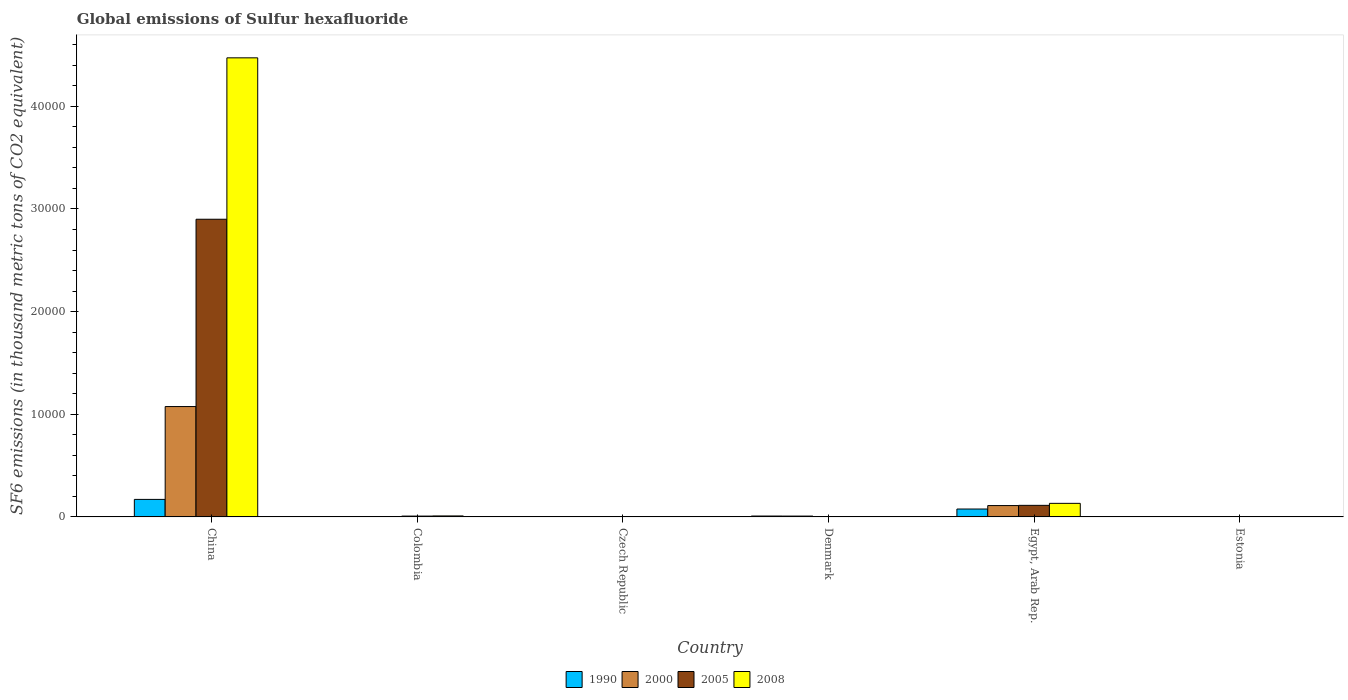How many different coloured bars are there?
Your answer should be very brief. 4. How many bars are there on the 4th tick from the right?
Your response must be concise. 4. In how many cases, is the number of bars for a given country not equal to the number of legend labels?
Your answer should be compact. 0. What is the global emissions of Sulfur hexafluoride in 2000 in Denmark?
Provide a succinct answer. 81.4. Across all countries, what is the maximum global emissions of Sulfur hexafluoride in 2000?
Provide a succinct answer. 1.08e+04. In which country was the global emissions of Sulfur hexafluoride in 2005 minimum?
Make the answer very short. Estonia. What is the total global emissions of Sulfur hexafluoride in 1990 in the graph?
Your answer should be very brief. 2611.6. What is the difference between the global emissions of Sulfur hexafluoride in 1990 in Denmark and that in Egypt, Arab Rep.?
Provide a short and direct response. -683. What is the difference between the global emissions of Sulfur hexafluoride in 2005 in Denmark and the global emissions of Sulfur hexafluoride in 2000 in Czech Republic?
Provide a succinct answer. 18.5. What is the average global emissions of Sulfur hexafluoride in 2000 per country?
Ensure brevity in your answer.  1997.55. What is the difference between the global emissions of Sulfur hexafluoride of/in 2000 and global emissions of Sulfur hexafluoride of/in 2005 in Czech Republic?
Offer a very short reply. 7.4. What is the ratio of the global emissions of Sulfur hexafluoride in 2000 in Colombia to that in Egypt, Arab Rep.?
Keep it short and to the point. 0.03. Is the global emissions of Sulfur hexafluoride in 2000 in Colombia less than that in Denmark?
Make the answer very short. Yes. Is the difference between the global emissions of Sulfur hexafluoride in 2000 in China and Estonia greater than the difference between the global emissions of Sulfur hexafluoride in 2005 in China and Estonia?
Give a very brief answer. No. What is the difference between the highest and the second highest global emissions of Sulfur hexafluoride in 2000?
Offer a terse response. -1.07e+04. What is the difference between the highest and the lowest global emissions of Sulfur hexafluoride in 1990?
Offer a terse response. 1707. Is the sum of the global emissions of Sulfur hexafluoride in 2000 in Czech Republic and Denmark greater than the maximum global emissions of Sulfur hexafluoride in 1990 across all countries?
Offer a very short reply. No. Is it the case that in every country, the sum of the global emissions of Sulfur hexafluoride in 2000 and global emissions of Sulfur hexafluoride in 1990 is greater than the sum of global emissions of Sulfur hexafluoride in 2005 and global emissions of Sulfur hexafluoride in 2008?
Your response must be concise. No. What does the 4th bar from the left in Estonia represents?
Ensure brevity in your answer.  2008. What does the 4th bar from the right in Egypt, Arab Rep. represents?
Ensure brevity in your answer.  1990. How many countries are there in the graph?
Ensure brevity in your answer.  6. Where does the legend appear in the graph?
Give a very brief answer. Bottom center. How are the legend labels stacked?
Keep it short and to the point. Horizontal. What is the title of the graph?
Your answer should be compact. Global emissions of Sulfur hexafluoride. What is the label or title of the X-axis?
Ensure brevity in your answer.  Country. What is the label or title of the Y-axis?
Offer a very short reply. SF6 emissions (in thousand metric tons of CO2 equivalent). What is the SF6 emissions (in thousand metric tons of CO2 equivalent) of 1990 in China?
Keep it short and to the point. 1708.6. What is the SF6 emissions (in thousand metric tons of CO2 equivalent) in 2000 in China?
Your answer should be very brief. 1.08e+04. What is the SF6 emissions (in thousand metric tons of CO2 equivalent) in 2005 in China?
Offer a terse response. 2.90e+04. What is the SF6 emissions (in thousand metric tons of CO2 equivalent) in 2008 in China?
Give a very brief answer. 4.47e+04. What is the SF6 emissions (in thousand metric tons of CO2 equivalent) of 1990 in Colombia?
Make the answer very short. 41.7. What is the SF6 emissions (in thousand metric tons of CO2 equivalent) in 2000 in Colombia?
Offer a terse response. 28.2. What is the SF6 emissions (in thousand metric tons of CO2 equivalent) of 2005 in Colombia?
Your answer should be compact. 82.9. What is the SF6 emissions (in thousand metric tons of CO2 equivalent) in 2008 in Colombia?
Your response must be concise. 96.7. What is the SF6 emissions (in thousand metric tons of CO2 equivalent) in 1990 in Czech Republic?
Your answer should be compact. 3.3. What is the SF6 emissions (in thousand metric tons of CO2 equivalent) in 2005 in Czech Republic?
Offer a very short reply. 5.6. What is the SF6 emissions (in thousand metric tons of CO2 equivalent) of 1990 in Denmark?
Offer a very short reply. 86.7. What is the SF6 emissions (in thousand metric tons of CO2 equivalent) in 2000 in Denmark?
Your answer should be compact. 81.4. What is the SF6 emissions (in thousand metric tons of CO2 equivalent) of 2005 in Denmark?
Your answer should be compact. 31.5. What is the SF6 emissions (in thousand metric tons of CO2 equivalent) of 2008 in Denmark?
Offer a very short reply. 33.5. What is the SF6 emissions (in thousand metric tons of CO2 equivalent) of 1990 in Egypt, Arab Rep.?
Ensure brevity in your answer.  769.7. What is the SF6 emissions (in thousand metric tons of CO2 equivalent) in 2000 in Egypt, Arab Rep.?
Offer a very short reply. 1107.1. What is the SF6 emissions (in thousand metric tons of CO2 equivalent) in 2005 in Egypt, Arab Rep.?
Offer a terse response. 1127.3. What is the SF6 emissions (in thousand metric tons of CO2 equivalent) in 2008 in Egypt, Arab Rep.?
Provide a succinct answer. 1323.3. What is the SF6 emissions (in thousand metric tons of CO2 equivalent) in 2005 in Estonia?
Your answer should be compact. 2.2. Across all countries, what is the maximum SF6 emissions (in thousand metric tons of CO2 equivalent) in 1990?
Offer a terse response. 1708.6. Across all countries, what is the maximum SF6 emissions (in thousand metric tons of CO2 equivalent) of 2000?
Offer a very short reply. 1.08e+04. Across all countries, what is the maximum SF6 emissions (in thousand metric tons of CO2 equivalent) of 2005?
Offer a terse response. 2.90e+04. Across all countries, what is the maximum SF6 emissions (in thousand metric tons of CO2 equivalent) in 2008?
Offer a terse response. 4.47e+04. Across all countries, what is the minimum SF6 emissions (in thousand metric tons of CO2 equivalent) in 2000?
Ensure brevity in your answer.  2. What is the total SF6 emissions (in thousand metric tons of CO2 equivalent) in 1990 in the graph?
Offer a terse response. 2611.6. What is the total SF6 emissions (in thousand metric tons of CO2 equivalent) of 2000 in the graph?
Provide a short and direct response. 1.20e+04. What is the total SF6 emissions (in thousand metric tons of CO2 equivalent) of 2005 in the graph?
Give a very brief answer. 3.03e+04. What is the total SF6 emissions (in thousand metric tons of CO2 equivalent) of 2008 in the graph?
Provide a short and direct response. 4.62e+04. What is the difference between the SF6 emissions (in thousand metric tons of CO2 equivalent) in 1990 in China and that in Colombia?
Your answer should be compact. 1666.9. What is the difference between the SF6 emissions (in thousand metric tons of CO2 equivalent) of 2000 in China and that in Colombia?
Offer a very short reply. 1.07e+04. What is the difference between the SF6 emissions (in thousand metric tons of CO2 equivalent) of 2005 in China and that in Colombia?
Offer a terse response. 2.89e+04. What is the difference between the SF6 emissions (in thousand metric tons of CO2 equivalent) in 2008 in China and that in Colombia?
Your answer should be compact. 4.46e+04. What is the difference between the SF6 emissions (in thousand metric tons of CO2 equivalent) in 1990 in China and that in Czech Republic?
Make the answer very short. 1705.3. What is the difference between the SF6 emissions (in thousand metric tons of CO2 equivalent) of 2000 in China and that in Czech Republic?
Keep it short and to the point. 1.07e+04. What is the difference between the SF6 emissions (in thousand metric tons of CO2 equivalent) of 2005 in China and that in Czech Republic?
Make the answer very short. 2.90e+04. What is the difference between the SF6 emissions (in thousand metric tons of CO2 equivalent) of 2008 in China and that in Czech Republic?
Your response must be concise. 4.47e+04. What is the difference between the SF6 emissions (in thousand metric tons of CO2 equivalent) of 1990 in China and that in Denmark?
Keep it short and to the point. 1621.9. What is the difference between the SF6 emissions (in thousand metric tons of CO2 equivalent) of 2000 in China and that in Denmark?
Your answer should be compact. 1.07e+04. What is the difference between the SF6 emissions (in thousand metric tons of CO2 equivalent) of 2005 in China and that in Denmark?
Your response must be concise. 2.90e+04. What is the difference between the SF6 emissions (in thousand metric tons of CO2 equivalent) in 2008 in China and that in Denmark?
Offer a terse response. 4.47e+04. What is the difference between the SF6 emissions (in thousand metric tons of CO2 equivalent) of 1990 in China and that in Egypt, Arab Rep.?
Provide a short and direct response. 938.9. What is the difference between the SF6 emissions (in thousand metric tons of CO2 equivalent) of 2000 in China and that in Egypt, Arab Rep.?
Keep it short and to the point. 9646.5. What is the difference between the SF6 emissions (in thousand metric tons of CO2 equivalent) in 2005 in China and that in Egypt, Arab Rep.?
Make the answer very short. 2.79e+04. What is the difference between the SF6 emissions (in thousand metric tons of CO2 equivalent) of 2008 in China and that in Egypt, Arab Rep.?
Make the answer very short. 4.34e+04. What is the difference between the SF6 emissions (in thousand metric tons of CO2 equivalent) in 1990 in China and that in Estonia?
Your answer should be compact. 1707. What is the difference between the SF6 emissions (in thousand metric tons of CO2 equivalent) of 2000 in China and that in Estonia?
Your answer should be compact. 1.08e+04. What is the difference between the SF6 emissions (in thousand metric tons of CO2 equivalent) in 2005 in China and that in Estonia?
Ensure brevity in your answer.  2.90e+04. What is the difference between the SF6 emissions (in thousand metric tons of CO2 equivalent) of 2008 in China and that in Estonia?
Keep it short and to the point. 4.47e+04. What is the difference between the SF6 emissions (in thousand metric tons of CO2 equivalent) in 1990 in Colombia and that in Czech Republic?
Provide a short and direct response. 38.4. What is the difference between the SF6 emissions (in thousand metric tons of CO2 equivalent) of 2000 in Colombia and that in Czech Republic?
Your answer should be very brief. 15.2. What is the difference between the SF6 emissions (in thousand metric tons of CO2 equivalent) of 2005 in Colombia and that in Czech Republic?
Keep it short and to the point. 77.3. What is the difference between the SF6 emissions (in thousand metric tons of CO2 equivalent) of 2008 in Colombia and that in Czech Republic?
Provide a short and direct response. 92. What is the difference between the SF6 emissions (in thousand metric tons of CO2 equivalent) in 1990 in Colombia and that in Denmark?
Make the answer very short. -45. What is the difference between the SF6 emissions (in thousand metric tons of CO2 equivalent) of 2000 in Colombia and that in Denmark?
Offer a very short reply. -53.2. What is the difference between the SF6 emissions (in thousand metric tons of CO2 equivalent) in 2005 in Colombia and that in Denmark?
Keep it short and to the point. 51.4. What is the difference between the SF6 emissions (in thousand metric tons of CO2 equivalent) in 2008 in Colombia and that in Denmark?
Provide a short and direct response. 63.2. What is the difference between the SF6 emissions (in thousand metric tons of CO2 equivalent) of 1990 in Colombia and that in Egypt, Arab Rep.?
Make the answer very short. -728. What is the difference between the SF6 emissions (in thousand metric tons of CO2 equivalent) of 2000 in Colombia and that in Egypt, Arab Rep.?
Your answer should be compact. -1078.9. What is the difference between the SF6 emissions (in thousand metric tons of CO2 equivalent) in 2005 in Colombia and that in Egypt, Arab Rep.?
Ensure brevity in your answer.  -1044.4. What is the difference between the SF6 emissions (in thousand metric tons of CO2 equivalent) of 2008 in Colombia and that in Egypt, Arab Rep.?
Provide a short and direct response. -1226.6. What is the difference between the SF6 emissions (in thousand metric tons of CO2 equivalent) in 1990 in Colombia and that in Estonia?
Offer a very short reply. 40.1. What is the difference between the SF6 emissions (in thousand metric tons of CO2 equivalent) in 2000 in Colombia and that in Estonia?
Ensure brevity in your answer.  26.2. What is the difference between the SF6 emissions (in thousand metric tons of CO2 equivalent) of 2005 in Colombia and that in Estonia?
Your answer should be compact. 80.7. What is the difference between the SF6 emissions (in thousand metric tons of CO2 equivalent) in 2008 in Colombia and that in Estonia?
Provide a succinct answer. 94.4. What is the difference between the SF6 emissions (in thousand metric tons of CO2 equivalent) of 1990 in Czech Republic and that in Denmark?
Your response must be concise. -83.4. What is the difference between the SF6 emissions (in thousand metric tons of CO2 equivalent) of 2000 in Czech Republic and that in Denmark?
Provide a succinct answer. -68.4. What is the difference between the SF6 emissions (in thousand metric tons of CO2 equivalent) of 2005 in Czech Republic and that in Denmark?
Your response must be concise. -25.9. What is the difference between the SF6 emissions (in thousand metric tons of CO2 equivalent) in 2008 in Czech Republic and that in Denmark?
Your response must be concise. -28.8. What is the difference between the SF6 emissions (in thousand metric tons of CO2 equivalent) of 1990 in Czech Republic and that in Egypt, Arab Rep.?
Offer a terse response. -766.4. What is the difference between the SF6 emissions (in thousand metric tons of CO2 equivalent) in 2000 in Czech Republic and that in Egypt, Arab Rep.?
Offer a terse response. -1094.1. What is the difference between the SF6 emissions (in thousand metric tons of CO2 equivalent) of 2005 in Czech Republic and that in Egypt, Arab Rep.?
Ensure brevity in your answer.  -1121.7. What is the difference between the SF6 emissions (in thousand metric tons of CO2 equivalent) of 2008 in Czech Republic and that in Egypt, Arab Rep.?
Your answer should be compact. -1318.6. What is the difference between the SF6 emissions (in thousand metric tons of CO2 equivalent) of 1990 in Czech Republic and that in Estonia?
Make the answer very short. 1.7. What is the difference between the SF6 emissions (in thousand metric tons of CO2 equivalent) in 2005 in Czech Republic and that in Estonia?
Give a very brief answer. 3.4. What is the difference between the SF6 emissions (in thousand metric tons of CO2 equivalent) of 2008 in Czech Republic and that in Estonia?
Ensure brevity in your answer.  2.4. What is the difference between the SF6 emissions (in thousand metric tons of CO2 equivalent) in 1990 in Denmark and that in Egypt, Arab Rep.?
Keep it short and to the point. -683. What is the difference between the SF6 emissions (in thousand metric tons of CO2 equivalent) in 2000 in Denmark and that in Egypt, Arab Rep.?
Make the answer very short. -1025.7. What is the difference between the SF6 emissions (in thousand metric tons of CO2 equivalent) of 2005 in Denmark and that in Egypt, Arab Rep.?
Ensure brevity in your answer.  -1095.8. What is the difference between the SF6 emissions (in thousand metric tons of CO2 equivalent) in 2008 in Denmark and that in Egypt, Arab Rep.?
Provide a short and direct response. -1289.8. What is the difference between the SF6 emissions (in thousand metric tons of CO2 equivalent) in 1990 in Denmark and that in Estonia?
Keep it short and to the point. 85.1. What is the difference between the SF6 emissions (in thousand metric tons of CO2 equivalent) of 2000 in Denmark and that in Estonia?
Keep it short and to the point. 79.4. What is the difference between the SF6 emissions (in thousand metric tons of CO2 equivalent) of 2005 in Denmark and that in Estonia?
Give a very brief answer. 29.3. What is the difference between the SF6 emissions (in thousand metric tons of CO2 equivalent) in 2008 in Denmark and that in Estonia?
Provide a short and direct response. 31.2. What is the difference between the SF6 emissions (in thousand metric tons of CO2 equivalent) of 1990 in Egypt, Arab Rep. and that in Estonia?
Provide a succinct answer. 768.1. What is the difference between the SF6 emissions (in thousand metric tons of CO2 equivalent) in 2000 in Egypt, Arab Rep. and that in Estonia?
Give a very brief answer. 1105.1. What is the difference between the SF6 emissions (in thousand metric tons of CO2 equivalent) in 2005 in Egypt, Arab Rep. and that in Estonia?
Offer a terse response. 1125.1. What is the difference between the SF6 emissions (in thousand metric tons of CO2 equivalent) in 2008 in Egypt, Arab Rep. and that in Estonia?
Keep it short and to the point. 1321. What is the difference between the SF6 emissions (in thousand metric tons of CO2 equivalent) in 1990 in China and the SF6 emissions (in thousand metric tons of CO2 equivalent) in 2000 in Colombia?
Give a very brief answer. 1680.4. What is the difference between the SF6 emissions (in thousand metric tons of CO2 equivalent) in 1990 in China and the SF6 emissions (in thousand metric tons of CO2 equivalent) in 2005 in Colombia?
Provide a succinct answer. 1625.7. What is the difference between the SF6 emissions (in thousand metric tons of CO2 equivalent) of 1990 in China and the SF6 emissions (in thousand metric tons of CO2 equivalent) of 2008 in Colombia?
Make the answer very short. 1611.9. What is the difference between the SF6 emissions (in thousand metric tons of CO2 equivalent) of 2000 in China and the SF6 emissions (in thousand metric tons of CO2 equivalent) of 2005 in Colombia?
Your response must be concise. 1.07e+04. What is the difference between the SF6 emissions (in thousand metric tons of CO2 equivalent) of 2000 in China and the SF6 emissions (in thousand metric tons of CO2 equivalent) of 2008 in Colombia?
Ensure brevity in your answer.  1.07e+04. What is the difference between the SF6 emissions (in thousand metric tons of CO2 equivalent) in 2005 in China and the SF6 emissions (in thousand metric tons of CO2 equivalent) in 2008 in Colombia?
Your answer should be very brief. 2.89e+04. What is the difference between the SF6 emissions (in thousand metric tons of CO2 equivalent) of 1990 in China and the SF6 emissions (in thousand metric tons of CO2 equivalent) of 2000 in Czech Republic?
Give a very brief answer. 1695.6. What is the difference between the SF6 emissions (in thousand metric tons of CO2 equivalent) of 1990 in China and the SF6 emissions (in thousand metric tons of CO2 equivalent) of 2005 in Czech Republic?
Ensure brevity in your answer.  1703. What is the difference between the SF6 emissions (in thousand metric tons of CO2 equivalent) in 1990 in China and the SF6 emissions (in thousand metric tons of CO2 equivalent) in 2008 in Czech Republic?
Ensure brevity in your answer.  1703.9. What is the difference between the SF6 emissions (in thousand metric tons of CO2 equivalent) in 2000 in China and the SF6 emissions (in thousand metric tons of CO2 equivalent) in 2005 in Czech Republic?
Your answer should be very brief. 1.07e+04. What is the difference between the SF6 emissions (in thousand metric tons of CO2 equivalent) of 2000 in China and the SF6 emissions (in thousand metric tons of CO2 equivalent) of 2008 in Czech Republic?
Offer a terse response. 1.07e+04. What is the difference between the SF6 emissions (in thousand metric tons of CO2 equivalent) in 2005 in China and the SF6 emissions (in thousand metric tons of CO2 equivalent) in 2008 in Czech Republic?
Provide a short and direct response. 2.90e+04. What is the difference between the SF6 emissions (in thousand metric tons of CO2 equivalent) in 1990 in China and the SF6 emissions (in thousand metric tons of CO2 equivalent) in 2000 in Denmark?
Your response must be concise. 1627.2. What is the difference between the SF6 emissions (in thousand metric tons of CO2 equivalent) of 1990 in China and the SF6 emissions (in thousand metric tons of CO2 equivalent) of 2005 in Denmark?
Your answer should be compact. 1677.1. What is the difference between the SF6 emissions (in thousand metric tons of CO2 equivalent) in 1990 in China and the SF6 emissions (in thousand metric tons of CO2 equivalent) in 2008 in Denmark?
Provide a short and direct response. 1675.1. What is the difference between the SF6 emissions (in thousand metric tons of CO2 equivalent) of 2000 in China and the SF6 emissions (in thousand metric tons of CO2 equivalent) of 2005 in Denmark?
Provide a short and direct response. 1.07e+04. What is the difference between the SF6 emissions (in thousand metric tons of CO2 equivalent) of 2000 in China and the SF6 emissions (in thousand metric tons of CO2 equivalent) of 2008 in Denmark?
Offer a very short reply. 1.07e+04. What is the difference between the SF6 emissions (in thousand metric tons of CO2 equivalent) in 2005 in China and the SF6 emissions (in thousand metric tons of CO2 equivalent) in 2008 in Denmark?
Make the answer very short. 2.90e+04. What is the difference between the SF6 emissions (in thousand metric tons of CO2 equivalent) in 1990 in China and the SF6 emissions (in thousand metric tons of CO2 equivalent) in 2000 in Egypt, Arab Rep.?
Offer a terse response. 601.5. What is the difference between the SF6 emissions (in thousand metric tons of CO2 equivalent) of 1990 in China and the SF6 emissions (in thousand metric tons of CO2 equivalent) of 2005 in Egypt, Arab Rep.?
Your answer should be very brief. 581.3. What is the difference between the SF6 emissions (in thousand metric tons of CO2 equivalent) in 1990 in China and the SF6 emissions (in thousand metric tons of CO2 equivalent) in 2008 in Egypt, Arab Rep.?
Offer a very short reply. 385.3. What is the difference between the SF6 emissions (in thousand metric tons of CO2 equivalent) in 2000 in China and the SF6 emissions (in thousand metric tons of CO2 equivalent) in 2005 in Egypt, Arab Rep.?
Provide a succinct answer. 9626.3. What is the difference between the SF6 emissions (in thousand metric tons of CO2 equivalent) of 2000 in China and the SF6 emissions (in thousand metric tons of CO2 equivalent) of 2008 in Egypt, Arab Rep.?
Offer a terse response. 9430.3. What is the difference between the SF6 emissions (in thousand metric tons of CO2 equivalent) in 2005 in China and the SF6 emissions (in thousand metric tons of CO2 equivalent) in 2008 in Egypt, Arab Rep.?
Offer a terse response. 2.77e+04. What is the difference between the SF6 emissions (in thousand metric tons of CO2 equivalent) in 1990 in China and the SF6 emissions (in thousand metric tons of CO2 equivalent) in 2000 in Estonia?
Keep it short and to the point. 1706.6. What is the difference between the SF6 emissions (in thousand metric tons of CO2 equivalent) in 1990 in China and the SF6 emissions (in thousand metric tons of CO2 equivalent) in 2005 in Estonia?
Your answer should be very brief. 1706.4. What is the difference between the SF6 emissions (in thousand metric tons of CO2 equivalent) in 1990 in China and the SF6 emissions (in thousand metric tons of CO2 equivalent) in 2008 in Estonia?
Offer a terse response. 1706.3. What is the difference between the SF6 emissions (in thousand metric tons of CO2 equivalent) of 2000 in China and the SF6 emissions (in thousand metric tons of CO2 equivalent) of 2005 in Estonia?
Your response must be concise. 1.08e+04. What is the difference between the SF6 emissions (in thousand metric tons of CO2 equivalent) in 2000 in China and the SF6 emissions (in thousand metric tons of CO2 equivalent) in 2008 in Estonia?
Ensure brevity in your answer.  1.08e+04. What is the difference between the SF6 emissions (in thousand metric tons of CO2 equivalent) in 2005 in China and the SF6 emissions (in thousand metric tons of CO2 equivalent) in 2008 in Estonia?
Provide a succinct answer. 2.90e+04. What is the difference between the SF6 emissions (in thousand metric tons of CO2 equivalent) of 1990 in Colombia and the SF6 emissions (in thousand metric tons of CO2 equivalent) of 2000 in Czech Republic?
Your answer should be very brief. 28.7. What is the difference between the SF6 emissions (in thousand metric tons of CO2 equivalent) of 1990 in Colombia and the SF6 emissions (in thousand metric tons of CO2 equivalent) of 2005 in Czech Republic?
Offer a very short reply. 36.1. What is the difference between the SF6 emissions (in thousand metric tons of CO2 equivalent) of 1990 in Colombia and the SF6 emissions (in thousand metric tons of CO2 equivalent) of 2008 in Czech Republic?
Your answer should be very brief. 37. What is the difference between the SF6 emissions (in thousand metric tons of CO2 equivalent) of 2000 in Colombia and the SF6 emissions (in thousand metric tons of CO2 equivalent) of 2005 in Czech Republic?
Ensure brevity in your answer.  22.6. What is the difference between the SF6 emissions (in thousand metric tons of CO2 equivalent) in 2000 in Colombia and the SF6 emissions (in thousand metric tons of CO2 equivalent) in 2008 in Czech Republic?
Give a very brief answer. 23.5. What is the difference between the SF6 emissions (in thousand metric tons of CO2 equivalent) of 2005 in Colombia and the SF6 emissions (in thousand metric tons of CO2 equivalent) of 2008 in Czech Republic?
Your response must be concise. 78.2. What is the difference between the SF6 emissions (in thousand metric tons of CO2 equivalent) in 1990 in Colombia and the SF6 emissions (in thousand metric tons of CO2 equivalent) in 2000 in Denmark?
Keep it short and to the point. -39.7. What is the difference between the SF6 emissions (in thousand metric tons of CO2 equivalent) in 1990 in Colombia and the SF6 emissions (in thousand metric tons of CO2 equivalent) in 2005 in Denmark?
Offer a terse response. 10.2. What is the difference between the SF6 emissions (in thousand metric tons of CO2 equivalent) of 2000 in Colombia and the SF6 emissions (in thousand metric tons of CO2 equivalent) of 2005 in Denmark?
Your answer should be very brief. -3.3. What is the difference between the SF6 emissions (in thousand metric tons of CO2 equivalent) in 2005 in Colombia and the SF6 emissions (in thousand metric tons of CO2 equivalent) in 2008 in Denmark?
Ensure brevity in your answer.  49.4. What is the difference between the SF6 emissions (in thousand metric tons of CO2 equivalent) in 1990 in Colombia and the SF6 emissions (in thousand metric tons of CO2 equivalent) in 2000 in Egypt, Arab Rep.?
Offer a terse response. -1065.4. What is the difference between the SF6 emissions (in thousand metric tons of CO2 equivalent) in 1990 in Colombia and the SF6 emissions (in thousand metric tons of CO2 equivalent) in 2005 in Egypt, Arab Rep.?
Offer a very short reply. -1085.6. What is the difference between the SF6 emissions (in thousand metric tons of CO2 equivalent) in 1990 in Colombia and the SF6 emissions (in thousand metric tons of CO2 equivalent) in 2008 in Egypt, Arab Rep.?
Ensure brevity in your answer.  -1281.6. What is the difference between the SF6 emissions (in thousand metric tons of CO2 equivalent) of 2000 in Colombia and the SF6 emissions (in thousand metric tons of CO2 equivalent) of 2005 in Egypt, Arab Rep.?
Your response must be concise. -1099.1. What is the difference between the SF6 emissions (in thousand metric tons of CO2 equivalent) of 2000 in Colombia and the SF6 emissions (in thousand metric tons of CO2 equivalent) of 2008 in Egypt, Arab Rep.?
Make the answer very short. -1295.1. What is the difference between the SF6 emissions (in thousand metric tons of CO2 equivalent) in 2005 in Colombia and the SF6 emissions (in thousand metric tons of CO2 equivalent) in 2008 in Egypt, Arab Rep.?
Provide a succinct answer. -1240.4. What is the difference between the SF6 emissions (in thousand metric tons of CO2 equivalent) in 1990 in Colombia and the SF6 emissions (in thousand metric tons of CO2 equivalent) in 2000 in Estonia?
Provide a short and direct response. 39.7. What is the difference between the SF6 emissions (in thousand metric tons of CO2 equivalent) in 1990 in Colombia and the SF6 emissions (in thousand metric tons of CO2 equivalent) in 2005 in Estonia?
Offer a very short reply. 39.5. What is the difference between the SF6 emissions (in thousand metric tons of CO2 equivalent) of 1990 in Colombia and the SF6 emissions (in thousand metric tons of CO2 equivalent) of 2008 in Estonia?
Your answer should be very brief. 39.4. What is the difference between the SF6 emissions (in thousand metric tons of CO2 equivalent) in 2000 in Colombia and the SF6 emissions (in thousand metric tons of CO2 equivalent) in 2008 in Estonia?
Provide a short and direct response. 25.9. What is the difference between the SF6 emissions (in thousand metric tons of CO2 equivalent) in 2005 in Colombia and the SF6 emissions (in thousand metric tons of CO2 equivalent) in 2008 in Estonia?
Ensure brevity in your answer.  80.6. What is the difference between the SF6 emissions (in thousand metric tons of CO2 equivalent) in 1990 in Czech Republic and the SF6 emissions (in thousand metric tons of CO2 equivalent) in 2000 in Denmark?
Ensure brevity in your answer.  -78.1. What is the difference between the SF6 emissions (in thousand metric tons of CO2 equivalent) in 1990 in Czech Republic and the SF6 emissions (in thousand metric tons of CO2 equivalent) in 2005 in Denmark?
Offer a terse response. -28.2. What is the difference between the SF6 emissions (in thousand metric tons of CO2 equivalent) in 1990 in Czech Republic and the SF6 emissions (in thousand metric tons of CO2 equivalent) in 2008 in Denmark?
Make the answer very short. -30.2. What is the difference between the SF6 emissions (in thousand metric tons of CO2 equivalent) in 2000 in Czech Republic and the SF6 emissions (in thousand metric tons of CO2 equivalent) in 2005 in Denmark?
Provide a short and direct response. -18.5. What is the difference between the SF6 emissions (in thousand metric tons of CO2 equivalent) of 2000 in Czech Republic and the SF6 emissions (in thousand metric tons of CO2 equivalent) of 2008 in Denmark?
Your answer should be very brief. -20.5. What is the difference between the SF6 emissions (in thousand metric tons of CO2 equivalent) of 2005 in Czech Republic and the SF6 emissions (in thousand metric tons of CO2 equivalent) of 2008 in Denmark?
Your response must be concise. -27.9. What is the difference between the SF6 emissions (in thousand metric tons of CO2 equivalent) of 1990 in Czech Republic and the SF6 emissions (in thousand metric tons of CO2 equivalent) of 2000 in Egypt, Arab Rep.?
Your response must be concise. -1103.8. What is the difference between the SF6 emissions (in thousand metric tons of CO2 equivalent) in 1990 in Czech Republic and the SF6 emissions (in thousand metric tons of CO2 equivalent) in 2005 in Egypt, Arab Rep.?
Give a very brief answer. -1124. What is the difference between the SF6 emissions (in thousand metric tons of CO2 equivalent) of 1990 in Czech Republic and the SF6 emissions (in thousand metric tons of CO2 equivalent) of 2008 in Egypt, Arab Rep.?
Your response must be concise. -1320. What is the difference between the SF6 emissions (in thousand metric tons of CO2 equivalent) of 2000 in Czech Republic and the SF6 emissions (in thousand metric tons of CO2 equivalent) of 2005 in Egypt, Arab Rep.?
Offer a terse response. -1114.3. What is the difference between the SF6 emissions (in thousand metric tons of CO2 equivalent) of 2000 in Czech Republic and the SF6 emissions (in thousand metric tons of CO2 equivalent) of 2008 in Egypt, Arab Rep.?
Offer a very short reply. -1310.3. What is the difference between the SF6 emissions (in thousand metric tons of CO2 equivalent) of 2005 in Czech Republic and the SF6 emissions (in thousand metric tons of CO2 equivalent) of 2008 in Egypt, Arab Rep.?
Offer a terse response. -1317.7. What is the difference between the SF6 emissions (in thousand metric tons of CO2 equivalent) of 1990 in Czech Republic and the SF6 emissions (in thousand metric tons of CO2 equivalent) of 2005 in Estonia?
Provide a short and direct response. 1.1. What is the difference between the SF6 emissions (in thousand metric tons of CO2 equivalent) of 2000 in Czech Republic and the SF6 emissions (in thousand metric tons of CO2 equivalent) of 2005 in Estonia?
Give a very brief answer. 10.8. What is the difference between the SF6 emissions (in thousand metric tons of CO2 equivalent) of 2000 in Czech Republic and the SF6 emissions (in thousand metric tons of CO2 equivalent) of 2008 in Estonia?
Provide a short and direct response. 10.7. What is the difference between the SF6 emissions (in thousand metric tons of CO2 equivalent) of 1990 in Denmark and the SF6 emissions (in thousand metric tons of CO2 equivalent) of 2000 in Egypt, Arab Rep.?
Your answer should be very brief. -1020.4. What is the difference between the SF6 emissions (in thousand metric tons of CO2 equivalent) in 1990 in Denmark and the SF6 emissions (in thousand metric tons of CO2 equivalent) in 2005 in Egypt, Arab Rep.?
Your response must be concise. -1040.6. What is the difference between the SF6 emissions (in thousand metric tons of CO2 equivalent) of 1990 in Denmark and the SF6 emissions (in thousand metric tons of CO2 equivalent) of 2008 in Egypt, Arab Rep.?
Keep it short and to the point. -1236.6. What is the difference between the SF6 emissions (in thousand metric tons of CO2 equivalent) of 2000 in Denmark and the SF6 emissions (in thousand metric tons of CO2 equivalent) of 2005 in Egypt, Arab Rep.?
Make the answer very short. -1045.9. What is the difference between the SF6 emissions (in thousand metric tons of CO2 equivalent) in 2000 in Denmark and the SF6 emissions (in thousand metric tons of CO2 equivalent) in 2008 in Egypt, Arab Rep.?
Provide a succinct answer. -1241.9. What is the difference between the SF6 emissions (in thousand metric tons of CO2 equivalent) in 2005 in Denmark and the SF6 emissions (in thousand metric tons of CO2 equivalent) in 2008 in Egypt, Arab Rep.?
Your response must be concise. -1291.8. What is the difference between the SF6 emissions (in thousand metric tons of CO2 equivalent) of 1990 in Denmark and the SF6 emissions (in thousand metric tons of CO2 equivalent) of 2000 in Estonia?
Your answer should be very brief. 84.7. What is the difference between the SF6 emissions (in thousand metric tons of CO2 equivalent) in 1990 in Denmark and the SF6 emissions (in thousand metric tons of CO2 equivalent) in 2005 in Estonia?
Your response must be concise. 84.5. What is the difference between the SF6 emissions (in thousand metric tons of CO2 equivalent) of 1990 in Denmark and the SF6 emissions (in thousand metric tons of CO2 equivalent) of 2008 in Estonia?
Offer a very short reply. 84.4. What is the difference between the SF6 emissions (in thousand metric tons of CO2 equivalent) in 2000 in Denmark and the SF6 emissions (in thousand metric tons of CO2 equivalent) in 2005 in Estonia?
Keep it short and to the point. 79.2. What is the difference between the SF6 emissions (in thousand metric tons of CO2 equivalent) of 2000 in Denmark and the SF6 emissions (in thousand metric tons of CO2 equivalent) of 2008 in Estonia?
Offer a terse response. 79.1. What is the difference between the SF6 emissions (in thousand metric tons of CO2 equivalent) of 2005 in Denmark and the SF6 emissions (in thousand metric tons of CO2 equivalent) of 2008 in Estonia?
Offer a terse response. 29.2. What is the difference between the SF6 emissions (in thousand metric tons of CO2 equivalent) in 1990 in Egypt, Arab Rep. and the SF6 emissions (in thousand metric tons of CO2 equivalent) in 2000 in Estonia?
Ensure brevity in your answer.  767.7. What is the difference between the SF6 emissions (in thousand metric tons of CO2 equivalent) in 1990 in Egypt, Arab Rep. and the SF6 emissions (in thousand metric tons of CO2 equivalent) in 2005 in Estonia?
Make the answer very short. 767.5. What is the difference between the SF6 emissions (in thousand metric tons of CO2 equivalent) of 1990 in Egypt, Arab Rep. and the SF6 emissions (in thousand metric tons of CO2 equivalent) of 2008 in Estonia?
Ensure brevity in your answer.  767.4. What is the difference between the SF6 emissions (in thousand metric tons of CO2 equivalent) in 2000 in Egypt, Arab Rep. and the SF6 emissions (in thousand metric tons of CO2 equivalent) in 2005 in Estonia?
Keep it short and to the point. 1104.9. What is the difference between the SF6 emissions (in thousand metric tons of CO2 equivalent) in 2000 in Egypt, Arab Rep. and the SF6 emissions (in thousand metric tons of CO2 equivalent) in 2008 in Estonia?
Your answer should be very brief. 1104.8. What is the difference between the SF6 emissions (in thousand metric tons of CO2 equivalent) of 2005 in Egypt, Arab Rep. and the SF6 emissions (in thousand metric tons of CO2 equivalent) of 2008 in Estonia?
Your response must be concise. 1125. What is the average SF6 emissions (in thousand metric tons of CO2 equivalent) of 1990 per country?
Offer a very short reply. 435.27. What is the average SF6 emissions (in thousand metric tons of CO2 equivalent) in 2000 per country?
Your answer should be compact. 1997.55. What is the average SF6 emissions (in thousand metric tons of CO2 equivalent) in 2005 per country?
Make the answer very short. 5041.7. What is the average SF6 emissions (in thousand metric tons of CO2 equivalent) in 2008 per country?
Your answer should be compact. 7697.78. What is the difference between the SF6 emissions (in thousand metric tons of CO2 equivalent) of 1990 and SF6 emissions (in thousand metric tons of CO2 equivalent) of 2000 in China?
Ensure brevity in your answer.  -9045. What is the difference between the SF6 emissions (in thousand metric tons of CO2 equivalent) of 1990 and SF6 emissions (in thousand metric tons of CO2 equivalent) of 2005 in China?
Offer a very short reply. -2.73e+04. What is the difference between the SF6 emissions (in thousand metric tons of CO2 equivalent) in 1990 and SF6 emissions (in thousand metric tons of CO2 equivalent) in 2008 in China?
Ensure brevity in your answer.  -4.30e+04. What is the difference between the SF6 emissions (in thousand metric tons of CO2 equivalent) of 2000 and SF6 emissions (in thousand metric tons of CO2 equivalent) of 2005 in China?
Give a very brief answer. -1.82e+04. What is the difference between the SF6 emissions (in thousand metric tons of CO2 equivalent) in 2000 and SF6 emissions (in thousand metric tons of CO2 equivalent) in 2008 in China?
Give a very brief answer. -3.40e+04. What is the difference between the SF6 emissions (in thousand metric tons of CO2 equivalent) of 2005 and SF6 emissions (in thousand metric tons of CO2 equivalent) of 2008 in China?
Keep it short and to the point. -1.57e+04. What is the difference between the SF6 emissions (in thousand metric tons of CO2 equivalent) of 1990 and SF6 emissions (in thousand metric tons of CO2 equivalent) of 2000 in Colombia?
Give a very brief answer. 13.5. What is the difference between the SF6 emissions (in thousand metric tons of CO2 equivalent) in 1990 and SF6 emissions (in thousand metric tons of CO2 equivalent) in 2005 in Colombia?
Your response must be concise. -41.2. What is the difference between the SF6 emissions (in thousand metric tons of CO2 equivalent) in 1990 and SF6 emissions (in thousand metric tons of CO2 equivalent) in 2008 in Colombia?
Your response must be concise. -55. What is the difference between the SF6 emissions (in thousand metric tons of CO2 equivalent) in 2000 and SF6 emissions (in thousand metric tons of CO2 equivalent) in 2005 in Colombia?
Provide a succinct answer. -54.7. What is the difference between the SF6 emissions (in thousand metric tons of CO2 equivalent) of 2000 and SF6 emissions (in thousand metric tons of CO2 equivalent) of 2008 in Colombia?
Offer a terse response. -68.5. What is the difference between the SF6 emissions (in thousand metric tons of CO2 equivalent) in 1990 and SF6 emissions (in thousand metric tons of CO2 equivalent) in 2000 in Denmark?
Offer a very short reply. 5.3. What is the difference between the SF6 emissions (in thousand metric tons of CO2 equivalent) of 1990 and SF6 emissions (in thousand metric tons of CO2 equivalent) of 2005 in Denmark?
Keep it short and to the point. 55.2. What is the difference between the SF6 emissions (in thousand metric tons of CO2 equivalent) in 1990 and SF6 emissions (in thousand metric tons of CO2 equivalent) in 2008 in Denmark?
Keep it short and to the point. 53.2. What is the difference between the SF6 emissions (in thousand metric tons of CO2 equivalent) in 2000 and SF6 emissions (in thousand metric tons of CO2 equivalent) in 2005 in Denmark?
Offer a terse response. 49.9. What is the difference between the SF6 emissions (in thousand metric tons of CO2 equivalent) in 2000 and SF6 emissions (in thousand metric tons of CO2 equivalent) in 2008 in Denmark?
Provide a succinct answer. 47.9. What is the difference between the SF6 emissions (in thousand metric tons of CO2 equivalent) in 2005 and SF6 emissions (in thousand metric tons of CO2 equivalent) in 2008 in Denmark?
Provide a succinct answer. -2. What is the difference between the SF6 emissions (in thousand metric tons of CO2 equivalent) of 1990 and SF6 emissions (in thousand metric tons of CO2 equivalent) of 2000 in Egypt, Arab Rep.?
Offer a terse response. -337.4. What is the difference between the SF6 emissions (in thousand metric tons of CO2 equivalent) of 1990 and SF6 emissions (in thousand metric tons of CO2 equivalent) of 2005 in Egypt, Arab Rep.?
Your answer should be very brief. -357.6. What is the difference between the SF6 emissions (in thousand metric tons of CO2 equivalent) in 1990 and SF6 emissions (in thousand metric tons of CO2 equivalent) in 2008 in Egypt, Arab Rep.?
Offer a very short reply. -553.6. What is the difference between the SF6 emissions (in thousand metric tons of CO2 equivalent) of 2000 and SF6 emissions (in thousand metric tons of CO2 equivalent) of 2005 in Egypt, Arab Rep.?
Your answer should be compact. -20.2. What is the difference between the SF6 emissions (in thousand metric tons of CO2 equivalent) of 2000 and SF6 emissions (in thousand metric tons of CO2 equivalent) of 2008 in Egypt, Arab Rep.?
Provide a short and direct response. -216.2. What is the difference between the SF6 emissions (in thousand metric tons of CO2 equivalent) of 2005 and SF6 emissions (in thousand metric tons of CO2 equivalent) of 2008 in Egypt, Arab Rep.?
Provide a short and direct response. -196. What is the difference between the SF6 emissions (in thousand metric tons of CO2 equivalent) in 1990 and SF6 emissions (in thousand metric tons of CO2 equivalent) in 2000 in Estonia?
Offer a very short reply. -0.4. What is the difference between the SF6 emissions (in thousand metric tons of CO2 equivalent) in 1990 and SF6 emissions (in thousand metric tons of CO2 equivalent) in 2005 in Estonia?
Make the answer very short. -0.6. What is the difference between the SF6 emissions (in thousand metric tons of CO2 equivalent) of 2000 and SF6 emissions (in thousand metric tons of CO2 equivalent) of 2005 in Estonia?
Ensure brevity in your answer.  -0.2. What is the ratio of the SF6 emissions (in thousand metric tons of CO2 equivalent) of 1990 in China to that in Colombia?
Your response must be concise. 40.97. What is the ratio of the SF6 emissions (in thousand metric tons of CO2 equivalent) in 2000 in China to that in Colombia?
Ensure brevity in your answer.  381.33. What is the ratio of the SF6 emissions (in thousand metric tons of CO2 equivalent) in 2005 in China to that in Colombia?
Your answer should be compact. 349.83. What is the ratio of the SF6 emissions (in thousand metric tons of CO2 equivalent) of 2008 in China to that in Colombia?
Make the answer very short. 462.53. What is the ratio of the SF6 emissions (in thousand metric tons of CO2 equivalent) in 1990 in China to that in Czech Republic?
Make the answer very short. 517.76. What is the ratio of the SF6 emissions (in thousand metric tons of CO2 equivalent) in 2000 in China to that in Czech Republic?
Your response must be concise. 827.2. What is the ratio of the SF6 emissions (in thousand metric tons of CO2 equivalent) in 2005 in China to that in Czech Republic?
Keep it short and to the point. 5178.7. What is the ratio of the SF6 emissions (in thousand metric tons of CO2 equivalent) in 2008 in China to that in Czech Republic?
Give a very brief answer. 9516.21. What is the ratio of the SF6 emissions (in thousand metric tons of CO2 equivalent) of 1990 in China to that in Denmark?
Keep it short and to the point. 19.71. What is the ratio of the SF6 emissions (in thousand metric tons of CO2 equivalent) of 2000 in China to that in Denmark?
Provide a short and direct response. 132.11. What is the ratio of the SF6 emissions (in thousand metric tons of CO2 equivalent) of 2005 in China to that in Denmark?
Make the answer very short. 920.66. What is the ratio of the SF6 emissions (in thousand metric tons of CO2 equivalent) of 2008 in China to that in Denmark?
Offer a very short reply. 1335.11. What is the ratio of the SF6 emissions (in thousand metric tons of CO2 equivalent) of 1990 in China to that in Egypt, Arab Rep.?
Make the answer very short. 2.22. What is the ratio of the SF6 emissions (in thousand metric tons of CO2 equivalent) of 2000 in China to that in Egypt, Arab Rep.?
Make the answer very short. 9.71. What is the ratio of the SF6 emissions (in thousand metric tons of CO2 equivalent) of 2005 in China to that in Egypt, Arab Rep.?
Offer a very short reply. 25.73. What is the ratio of the SF6 emissions (in thousand metric tons of CO2 equivalent) in 2008 in China to that in Egypt, Arab Rep.?
Provide a succinct answer. 33.8. What is the ratio of the SF6 emissions (in thousand metric tons of CO2 equivalent) of 1990 in China to that in Estonia?
Provide a succinct answer. 1067.88. What is the ratio of the SF6 emissions (in thousand metric tons of CO2 equivalent) in 2000 in China to that in Estonia?
Make the answer very short. 5376.8. What is the ratio of the SF6 emissions (in thousand metric tons of CO2 equivalent) in 2005 in China to that in Estonia?
Ensure brevity in your answer.  1.32e+04. What is the ratio of the SF6 emissions (in thousand metric tons of CO2 equivalent) of 2008 in China to that in Estonia?
Provide a succinct answer. 1.94e+04. What is the ratio of the SF6 emissions (in thousand metric tons of CO2 equivalent) of 1990 in Colombia to that in Czech Republic?
Your answer should be very brief. 12.64. What is the ratio of the SF6 emissions (in thousand metric tons of CO2 equivalent) of 2000 in Colombia to that in Czech Republic?
Ensure brevity in your answer.  2.17. What is the ratio of the SF6 emissions (in thousand metric tons of CO2 equivalent) in 2005 in Colombia to that in Czech Republic?
Your response must be concise. 14.8. What is the ratio of the SF6 emissions (in thousand metric tons of CO2 equivalent) of 2008 in Colombia to that in Czech Republic?
Your answer should be compact. 20.57. What is the ratio of the SF6 emissions (in thousand metric tons of CO2 equivalent) in 1990 in Colombia to that in Denmark?
Your answer should be compact. 0.48. What is the ratio of the SF6 emissions (in thousand metric tons of CO2 equivalent) in 2000 in Colombia to that in Denmark?
Give a very brief answer. 0.35. What is the ratio of the SF6 emissions (in thousand metric tons of CO2 equivalent) of 2005 in Colombia to that in Denmark?
Ensure brevity in your answer.  2.63. What is the ratio of the SF6 emissions (in thousand metric tons of CO2 equivalent) of 2008 in Colombia to that in Denmark?
Provide a succinct answer. 2.89. What is the ratio of the SF6 emissions (in thousand metric tons of CO2 equivalent) of 1990 in Colombia to that in Egypt, Arab Rep.?
Your response must be concise. 0.05. What is the ratio of the SF6 emissions (in thousand metric tons of CO2 equivalent) of 2000 in Colombia to that in Egypt, Arab Rep.?
Offer a very short reply. 0.03. What is the ratio of the SF6 emissions (in thousand metric tons of CO2 equivalent) of 2005 in Colombia to that in Egypt, Arab Rep.?
Give a very brief answer. 0.07. What is the ratio of the SF6 emissions (in thousand metric tons of CO2 equivalent) of 2008 in Colombia to that in Egypt, Arab Rep.?
Provide a succinct answer. 0.07. What is the ratio of the SF6 emissions (in thousand metric tons of CO2 equivalent) of 1990 in Colombia to that in Estonia?
Your answer should be very brief. 26.06. What is the ratio of the SF6 emissions (in thousand metric tons of CO2 equivalent) of 2000 in Colombia to that in Estonia?
Keep it short and to the point. 14.1. What is the ratio of the SF6 emissions (in thousand metric tons of CO2 equivalent) in 2005 in Colombia to that in Estonia?
Provide a short and direct response. 37.68. What is the ratio of the SF6 emissions (in thousand metric tons of CO2 equivalent) of 2008 in Colombia to that in Estonia?
Your answer should be compact. 42.04. What is the ratio of the SF6 emissions (in thousand metric tons of CO2 equivalent) of 1990 in Czech Republic to that in Denmark?
Make the answer very short. 0.04. What is the ratio of the SF6 emissions (in thousand metric tons of CO2 equivalent) in 2000 in Czech Republic to that in Denmark?
Provide a succinct answer. 0.16. What is the ratio of the SF6 emissions (in thousand metric tons of CO2 equivalent) of 2005 in Czech Republic to that in Denmark?
Offer a terse response. 0.18. What is the ratio of the SF6 emissions (in thousand metric tons of CO2 equivalent) of 2008 in Czech Republic to that in Denmark?
Make the answer very short. 0.14. What is the ratio of the SF6 emissions (in thousand metric tons of CO2 equivalent) in 1990 in Czech Republic to that in Egypt, Arab Rep.?
Ensure brevity in your answer.  0. What is the ratio of the SF6 emissions (in thousand metric tons of CO2 equivalent) of 2000 in Czech Republic to that in Egypt, Arab Rep.?
Provide a short and direct response. 0.01. What is the ratio of the SF6 emissions (in thousand metric tons of CO2 equivalent) in 2005 in Czech Republic to that in Egypt, Arab Rep.?
Your response must be concise. 0.01. What is the ratio of the SF6 emissions (in thousand metric tons of CO2 equivalent) of 2008 in Czech Republic to that in Egypt, Arab Rep.?
Make the answer very short. 0. What is the ratio of the SF6 emissions (in thousand metric tons of CO2 equivalent) of 1990 in Czech Republic to that in Estonia?
Your answer should be very brief. 2.06. What is the ratio of the SF6 emissions (in thousand metric tons of CO2 equivalent) in 2005 in Czech Republic to that in Estonia?
Offer a terse response. 2.55. What is the ratio of the SF6 emissions (in thousand metric tons of CO2 equivalent) of 2008 in Czech Republic to that in Estonia?
Your answer should be compact. 2.04. What is the ratio of the SF6 emissions (in thousand metric tons of CO2 equivalent) of 1990 in Denmark to that in Egypt, Arab Rep.?
Provide a succinct answer. 0.11. What is the ratio of the SF6 emissions (in thousand metric tons of CO2 equivalent) of 2000 in Denmark to that in Egypt, Arab Rep.?
Your response must be concise. 0.07. What is the ratio of the SF6 emissions (in thousand metric tons of CO2 equivalent) of 2005 in Denmark to that in Egypt, Arab Rep.?
Offer a terse response. 0.03. What is the ratio of the SF6 emissions (in thousand metric tons of CO2 equivalent) in 2008 in Denmark to that in Egypt, Arab Rep.?
Provide a succinct answer. 0.03. What is the ratio of the SF6 emissions (in thousand metric tons of CO2 equivalent) of 1990 in Denmark to that in Estonia?
Ensure brevity in your answer.  54.19. What is the ratio of the SF6 emissions (in thousand metric tons of CO2 equivalent) of 2000 in Denmark to that in Estonia?
Offer a terse response. 40.7. What is the ratio of the SF6 emissions (in thousand metric tons of CO2 equivalent) of 2005 in Denmark to that in Estonia?
Provide a succinct answer. 14.32. What is the ratio of the SF6 emissions (in thousand metric tons of CO2 equivalent) in 2008 in Denmark to that in Estonia?
Your answer should be compact. 14.57. What is the ratio of the SF6 emissions (in thousand metric tons of CO2 equivalent) in 1990 in Egypt, Arab Rep. to that in Estonia?
Your response must be concise. 481.06. What is the ratio of the SF6 emissions (in thousand metric tons of CO2 equivalent) in 2000 in Egypt, Arab Rep. to that in Estonia?
Provide a succinct answer. 553.55. What is the ratio of the SF6 emissions (in thousand metric tons of CO2 equivalent) in 2005 in Egypt, Arab Rep. to that in Estonia?
Provide a succinct answer. 512.41. What is the ratio of the SF6 emissions (in thousand metric tons of CO2 equivalent) of 2008 in Egypt, Arab Rep. to that in Estonia?
Provide a succinct answer. 575.35. What is the difference between the highest and the second highest SF6 emissions (in thousand metric tons of CO2 equivalent) of 1990?
Keep it short and to the point. 938.9. What is the difference between the highest and the second highest SF6 emissions (in thousand metric tons of CO2 equivalent) of 2000?
Make the answer very short. 9646.5. What is the difference between the highest and the second highest SF6 emissions (in thousand metric tons of CO2 equivalent) of 2005?
Your answer should be compact. 2.79e+04. What is the difference between the highest and the second highest SF6 emissions (in thousand metric tons of CO2 equivalent) in 2008?
Your answer should be very brief. 4.34e+04. What is the difference between the highest and the lowest SF6 emissions (in thousand metric tons of CO2 equivalent) of 1990?
Keep it short and to the point. 1707. What is the difference between the highest and the lowest SF6 emissions (in thousand metric tons of CO2 equivalent) of 2000?
Give a very brief answer. 1.08e+04. What is the difference between the highest and the lowest SF6 emissions (in thousand metric tons of CO2 equivalent) of 2005?
Keep it short and to the point. 2.90e+04. What is the difference between the highest and the lowest SF6 emissions (in thousand metric tons of CO2 equivalent) of 2008?
Your answer should be compact. 4.47e+04. 